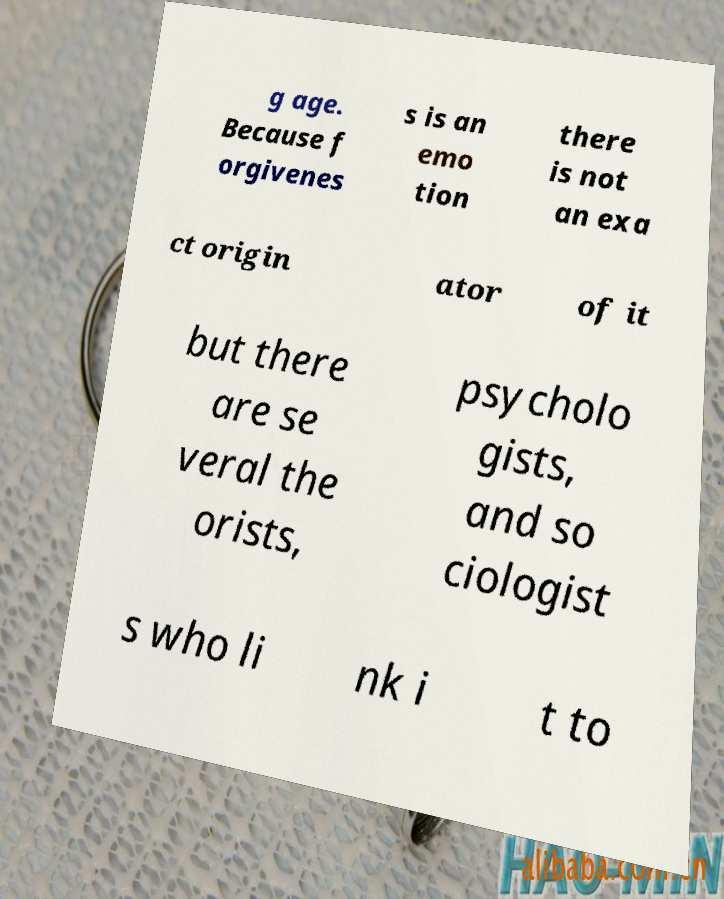Can you read and provide the text displayed in the image?This photo seems to have some interesting text. Can you extract and type it out for me? g age. Because f orgivenes s is an emo tion there is not an exa ct origin ator of it but there are se veral the orists, psycholo gists, and so ciologist s who li nk i t to 